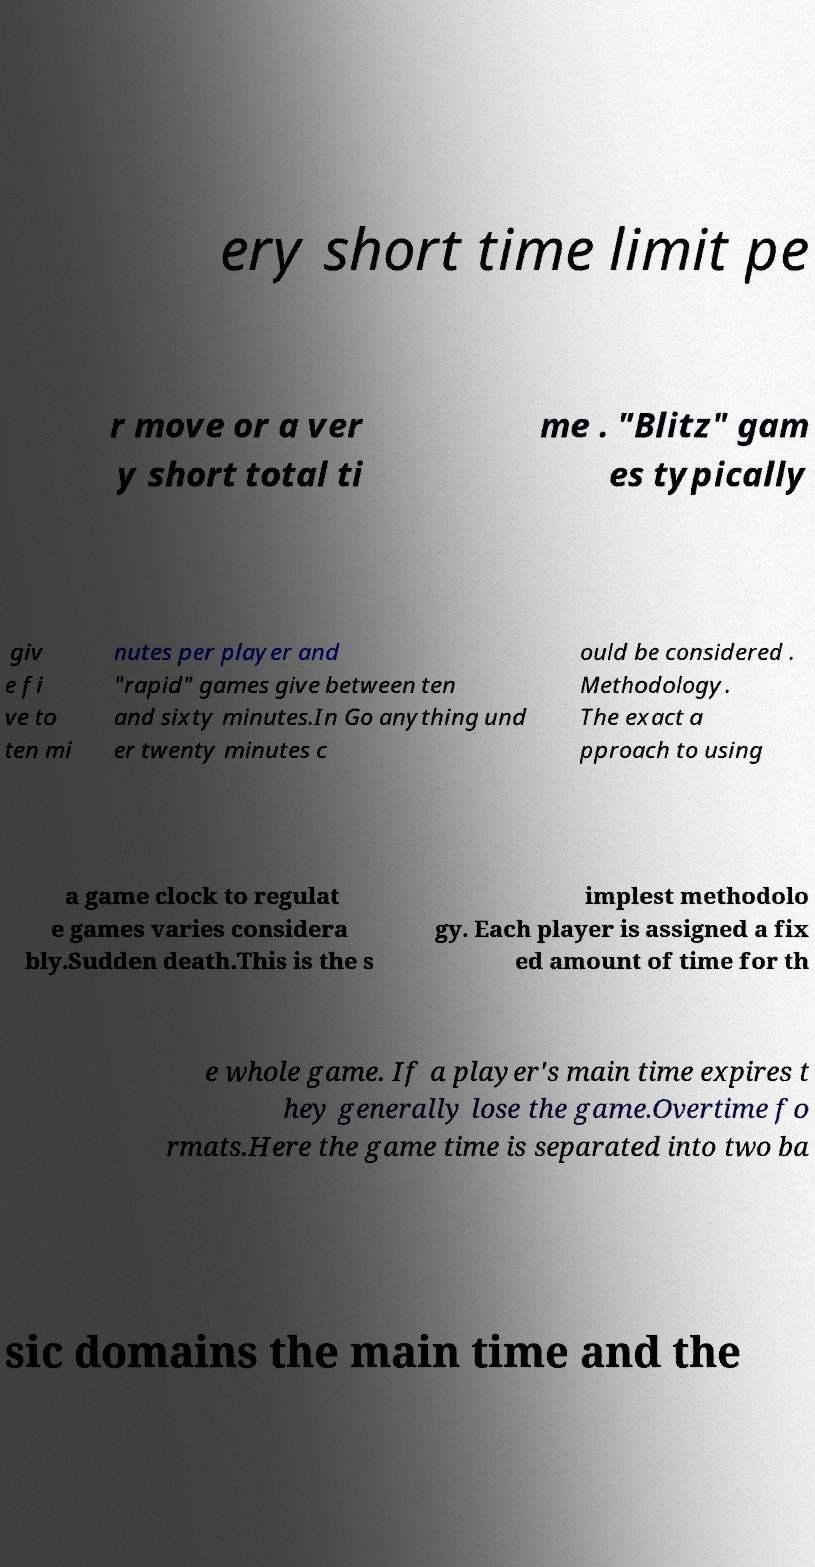Could you extract and type out the text from this image? ery short time limit pe r move or a ver y short total ti me . "Blitz" gam es typically giv e fi ve to ten mi nutes per player and "rapid" games give between ten and sixty minutes.In Go anything und er twenty minutes c ould be considered . Methodology. The exact a pproach to using a game clock to regulat e games varies considera bly.Sudden death.This is the s implest methodolo gy. Each player is assigned a fix ed amount of time for th e whole game. If a player's main time expires t hey generally lose the game.Overtime fo rmats.Here the game time is separated into two ba sic domains the main time and the 